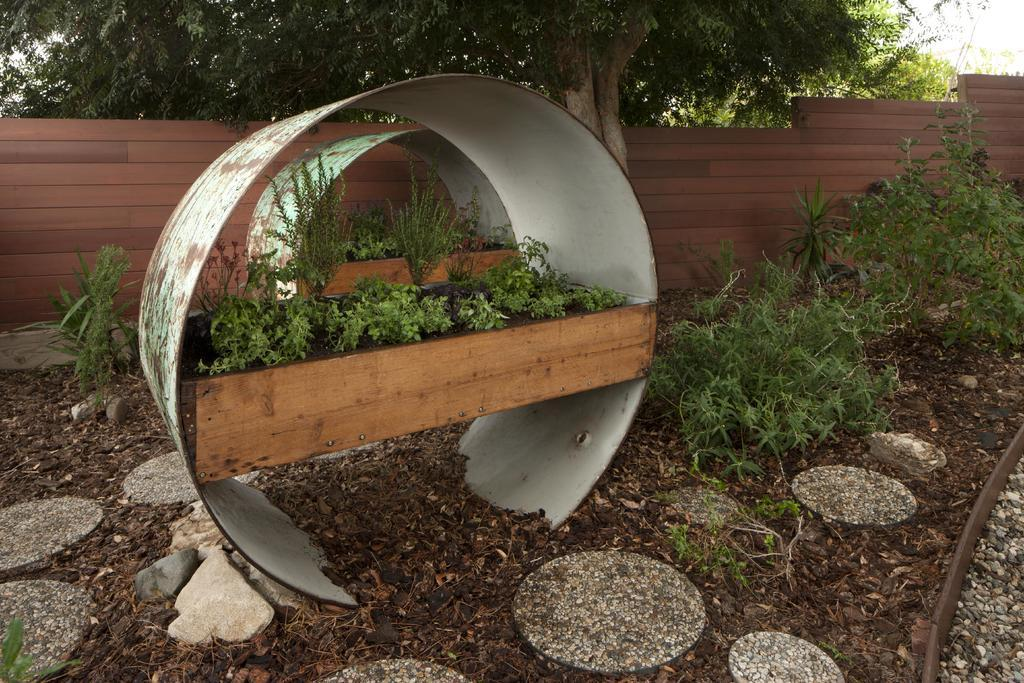What is placed on the wooden plank in the center of the image? There are plants placed on a wooden plank in the center of the image. What type of vegetation is at the bottom of the image? There are shrubs at the bottom of the image. What can be seen in the background of the image? There are trees and a wall in the background of the image. How many tickets are visible in the image? There are no tickets present in the image. What type of hill can be seen in the background of the image? There is no hill visible in the image; only trees, a wall, and plants are present. 